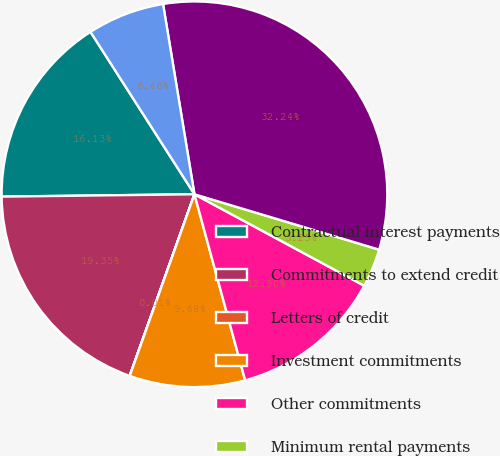Convert chart. <chart><loc_0><loc_0><loc_500><loc_500><pie_chart><fcel>Contractual interest payments<fcel>Commitments to extend credit<fcel>Letters of credit<fcel>Investment commitments<fcel>Other commitments<fcel>Minimum rental payments<fcel>Derivative guarantees<fcel>Other financial guarantees<nl><fcel>16.13%<fcel>19.35%<fcel>0.01%<fcel>9.68%<fcel>12.9%<fcel>3.23%<fcel>32.24%<fcel>6.46%<nl></chart> 